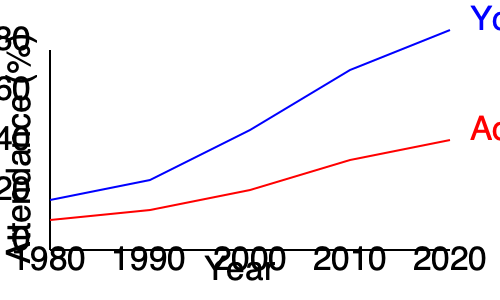Based on the line graph showing church attendance trends from 1980 to 2020, what conclusion can be drawn about the generational differences in church attendance, and how might this data influence the youth group leader's proposed changes? To answer this question, let's analyze the graph step by step:

1. Identify the lines:
   - Blue line represents youth attendance
   - Red line represents adult attendance

2. Observe the trends:
   - Youth attendance (blue line):
     - Starts at about 40% in 1980
     - Steadily increases to about 70% by 2020
   - Adult attendance (red line):
     - Starts at about 36% in 1980
     - Gradually decreases to about 32% by 2020

3. Compare the trends:
   - Youth attendance is increasing over time
   - Adult attendance is slightly decreasing over time
   - The gap between youth and adult attendance widens significantly

4. Draw conclusions:
   - There is a clear generational difference in church attendance
   - Youth are becoming more engaged in church activities over time
   - Adults are becoming slightly less engaged over time

5. Consider the youth group leader's perspective:
   - The increasing youth attendance suggests that current youth programs are effective
   - The leader may want to implement changes to further improve youth engagement
   - Changes might also aim to address the declining adult attendance

6. Consider the traditional perspective:
   - The declining adult attendance might be concerning for those who value tradition
   - Changes proposed by the youth leader could potentially alienate adult members
   - There may be a need to balance new initiatives with traditional practices

Given this analysis, the youth group leader's proposed changes are likely aimed at capitalizing on the positive trend in youth attendance while potentially addressing the decline in adult attendance. However, these changes may face resistance from those who value tradition and are concerned about further alienating adult members.
Answer: Youth attendance is increasing while adult attendance is decreasing, suggesting generational differences that the youth leader aims to address, but may face resistance from traditionalists. 